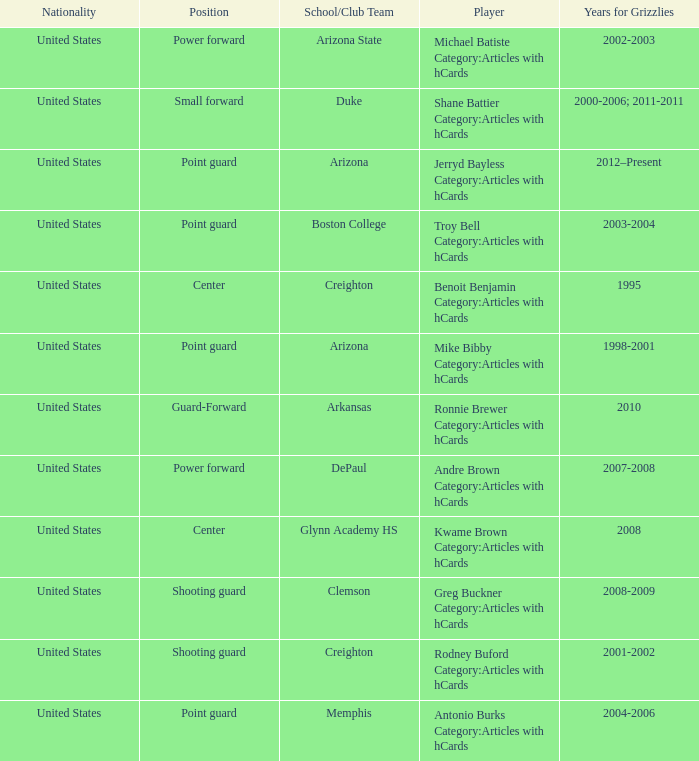Which Player has Years for Grizzlies of 2002-2003? Michael Batiste Category:Articles with hCards. 